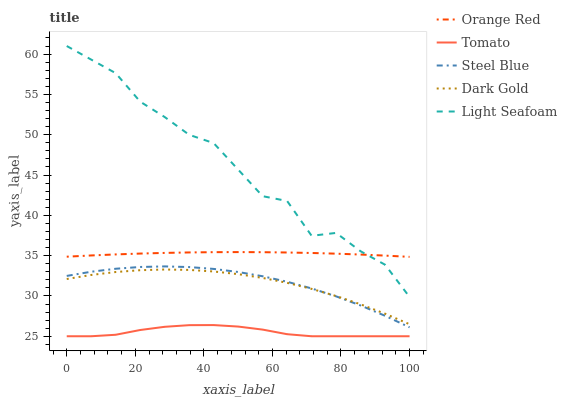Does Tomato have the minimum area under the curve?
Answer yes or no. Yes. Does Light Seafoam have the maximum area under the curve?
Answer yes or no. Yes. Does Dark Gold have the minimum area under the curve?
Answer yes or no. No. Does Dark Gold have the maximum area under the curve?
Answer yes or no. No. Is Orange Red the smoothest?
Answer yes or no. Yes. Is Light Seafoam the roughest?
Answer yes or no. Yes. Is Dark Gold the smoothest?
Answer yes or no. No. Is Dark Gold the roughest?
Answer yes or no. No. Does Tomato have the lowest value?
Answer yes or no. Yes. Does Dark Gold have the lowest value?
Answer yes or no. No. Does Light Seafoam have the highest value?
Answer yes or no. Yes. Does Dark Gold have the highest value?
Answer yes or no. No. Is Steel Blue less than Light Seafoam?
Answer yes or no. Yes. Is Orange Red greater than Tomato?
Answer yes or no. Yes. Does Steel Blue intersect Dark Gold?
Answer yes or no. Yes. Is Steel Blue less than Dark Gold?
Answer yes or no. No. Is Steel Blue greater than Dark Gold?
Answer yes or no. No. Does Steel Blue intersect Light Seafoam?
Answer yes or no. No. 